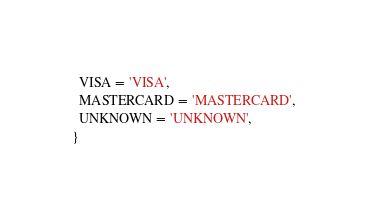<code> <loc_0><loc_0><loc_500><loc_500><_TypeScript_>  VISA = 'VISA',
  MASTERCARD = 'MASTERCARD',
  UNKNOWN = 'UNKNOWN',
}
</code> 